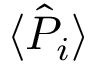<formula> <loc_0><loc_0><loc_500><loc_500>\langle \hat { P } _ { i } \rangle</formula> 